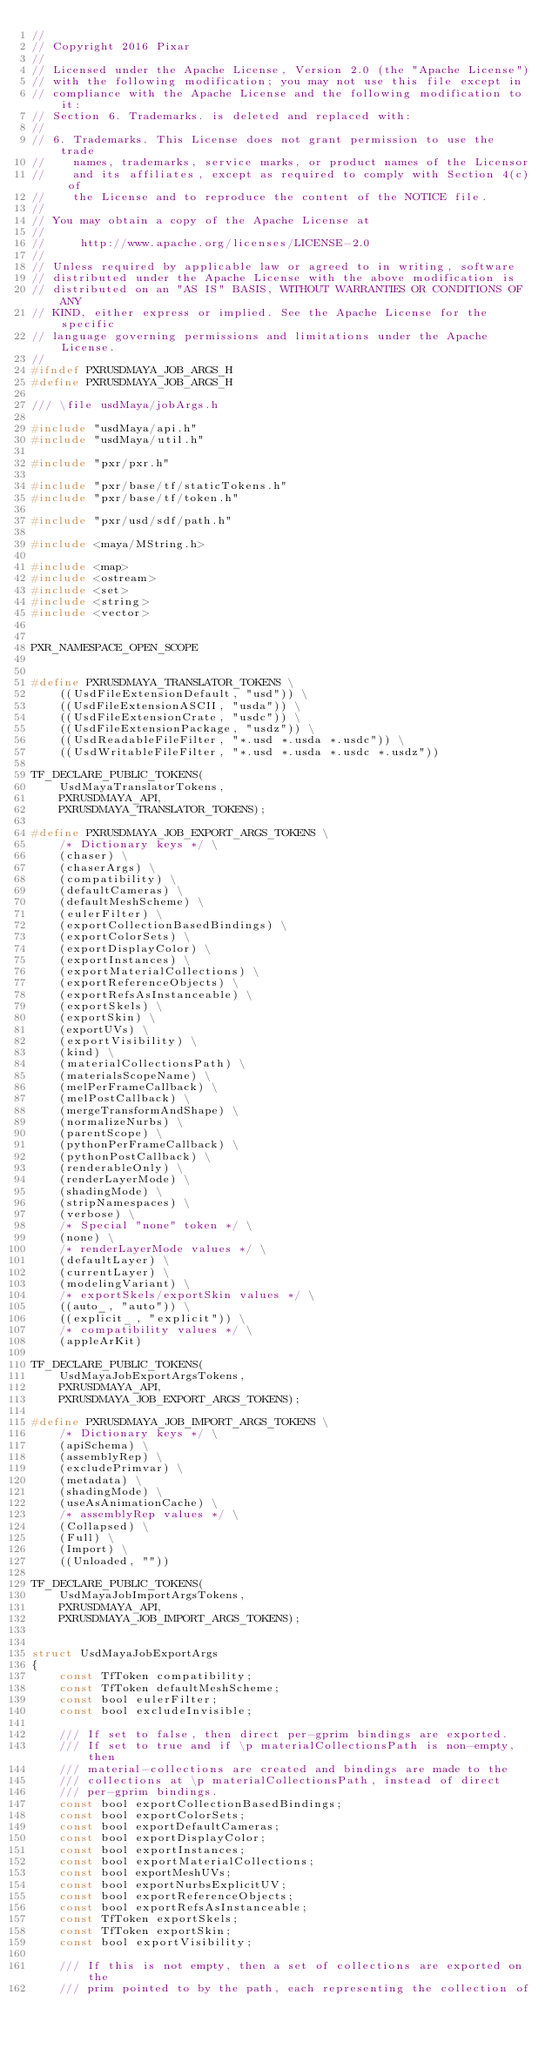Convert code to text. <code><loc_0><loc_0><loc_500><loc_500><_C_>//
// Copyright 2016 Pixar
//
// Licensed under the Apache License, Version 2.0 (the "Apache License")
// with the following modification; you may not use this file except in
// compliance with the Apache License and the following modification to it:
// Section 6. Trademarks. is deleted and replaced with:
//
// 6. Trademarks. This License does not grant permission to use the trade
//    names, trademarks, service marks, or product names of the Licensor
//    and its affiliates, except as required to comply with Section 4(c) of
//    the License and to reproduce the content of the NOTICE file.
//
// You may obtain a copy of the Apache License at
//
//     http://www.apache.org/licenses/LICENSE-2.0
//
// Unless required by applicable law or agreed to in writing, software
// distributed under the Apache License with the above modification is
// distributed on an "AS IS" BASIS, WITHOUT WARRANTIES OR CONDITIONS OF ANY
// KIND, either express or implied. See the Apache License for the specific
// language governing permissions and limitations under the Apache License.
//
#ifndef PXRUSDMAYA_JOB_ARGS_H
#define PXRUSDMAYA_JOB_ARGS_H

/// \file usdMaya/jobArgs.h

#include "usdMaya/api.h"
#include "usdMaya/util.h"

#include "pxr/pxr.h"

#include "pxr/base/tf/staticTokens.h"
#include "pxr/base/tf/token.h"

#include "pxr/usd/sdf/path.h"

#include <maya/MString.h>

#include <map>
#include <ostream>
#include <set>
#include <string>
#include <vector>


PXR_NAMESPACE_OPEN_SCOPE


#define PXRUSDMAYA_TRANSLATOR_TOKENS \
    ((UsdFileExtensionDefault, "usd")) \
    ((UsdFileExtensionASCII, "usda")) \
    ((UsdFileExtensionCrate, "usdc")) \
    ((UsdFileExtensionPackage, "usdz")) \
    ((UsdReadableFileFilter, "*.usd *.usda *.usdc")) \
    ((UsdWritableFileFilter, "*.usd *.usda *.usdc *.usdz"))

TF_DECLARE_PUBLIC_TOKENS(
    UsdMayaTranslatorTokens,
    PXRUSDMAYA_API,
    PXRUSDMAYA_TRANSLATOR_TOKENS);

#define PXRUSDMAYA_JOB_EXPORT_ARGS_TOKENS \
    /* Dictionary keys */ \
    (chaser) \
    (chaserArgs) \
    (compatibility) \
    (defaultCameras) \
    (defaultMeshScheme) \
    (eulerFilter) \
    (exportCollectionBasedBindings) \
    (exportColorSets) \
    (exportDisplayColor) \
    (exportInstances) \
    (exportMaterialCollections) \
    (exportReferenceObjects) \
    (exportRefsAsInstanceable) \
    (exportSkels) \
    (exportSkin) \
    (exportUVs) \
    (exportVisibility) \
    (kind) \
    (materialCollectionsPath) \
    (materialsScopeName) \
    (melPerFrameCallback) \
    (melPostCallback) \
    (mergeTransformAndShape) \
    (normalizeNurbs) \
    (parentScope) \
    (pythonPerFrameCallback) \
    (pythonPostCallback) \
    (renderableOnly) \
    (renderLayerMode) \
    (shadingMode) \
    (stripNamespaces) \
    (verbose) \
    /* Special "none" token */ \
    (none) \
    /* renderLayerMode values */ \
    (defaultLayer) \
    (currentLayer) \
    (modelingVariant) \
    /* exportSkels/exportSkin values */ \
    ((auto_, "auto")) \
    ((explicit_, "explicit")) \
    /* compatibility values */ \
    (appleArKit)

TF_DECLARE_PUBLIC_TOKENS(
    UsdMayaJobExportArgsTokens,
    PXRUSDMAYA_API,
    PXRUSDMAYA_JOB_EXPORT_ARGS_TOKENS);

#define PXRUSDMAYA_JOB_IMPORT_ARGS_TOKENS \
    /* Dictionary keys */ \
    (apiSchema) \
    (assemblyRep) \
    (excludePrimvar) \
    (metadata) \
    (shadingMode) \
    (useAsAnimationCache) \
    /* assemblyRep values */ \
    (Collapsed) \
    (Full) \
    (Import) \
    ((Unloaded, ""))

TF_DECLARE_PUBLIC_TOKENS(
    UsdMayaJobImportArgsTokens,
    PXRUSDMAYA_API,
    PXRUSDMAYA_JOB_IMPORT_ARGS_TOKENS);


struct UsdMayaJobExportArgs
{
    const TfToken compatibility;
    const TfToken defaultMeshScheme;
    const bool eulerFilter;
    const bool excludeInvisible;

    /// If set to false, then direct per-gprim bindings are exported.
    /// If set to true and if \p materialCollectionsPath is non-empty, then
    /// material-collections are created and bindings are made to the
    /// collections at \p materialCollectionsPath, instead of direct
    /// per-gprim bindings.
    const bool exportCollectionBasedBindings;
    const bool exportColorSets;
    const bool exportDefaultCameras;
    const bool exportDisplayColor;
    const bool exportInstances;
    const bool exportMaterialCollections;
    const bool exportMeshUVs;
    const bool exportNurbsExplicitUV;
    const bool exportReferenceObjects;
    const bool exportRefsAsInstanceable;
    const TfToken exportSkels;
    const TfToken exportSkin;
    const bool exportVisibility;

    /// If this is not empty, then a set of collections are exported on the
    /// prim pointed to by the path, each representing the collection of</code> 